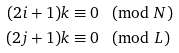<formula> <loc_0><loc_0><loc_500><loc_500>( 2 i + 1 ) k & \equiv 0 \pmod { N } \\ ( 2 j + 1 ) k & \equiv 0 \pmod { L }</formula> 